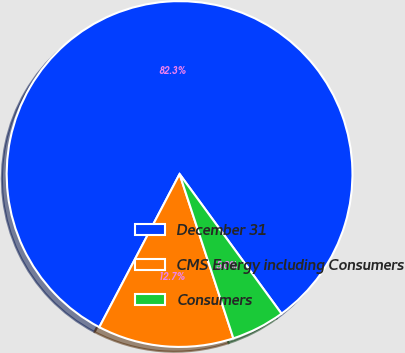Convert chart to OTSL. <chart><loc_0><loc_0><loc_500><loc_500><pie_chart><fcel>December 31<fcel>CMS Energy including Consumers<fcel>Consumers<nl><fcel>82.28%<fcel>12.72%<fcel>5.0%<nl></chart> 